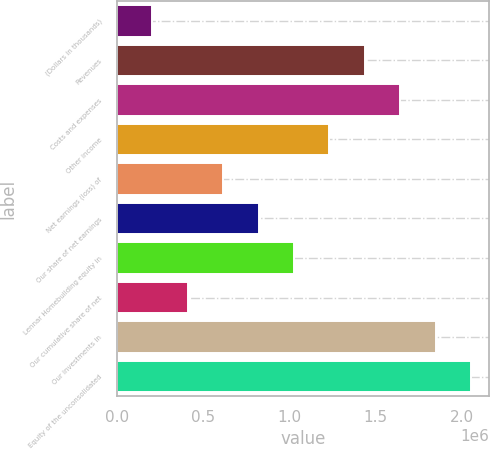<chart> <loc_0><loc_0><loc_500><loc_500><bar_chart><fcel>(Dollars in thousands)<fcel>Revenues<fcel>Costs and expenses<fcel>Other income<fcel>Net earnings (loss) of<fcel>Our share of net earnings<fcel>Lennar Homebuilding equity in<fcel>Our cumulative share of net<fcel>Our investments in<fcel>Equity of the unconsolidated<nl><fcel>205621<fcel>1.43918e+06<fcel>1.64478e+06<fcel>1.23359e+06<fcel>616809<fcel>822403<fcel>1.028e+06<fcel>411215<fcel>1.85037e+06<fcel>2.05597e+06<nl></chart> 